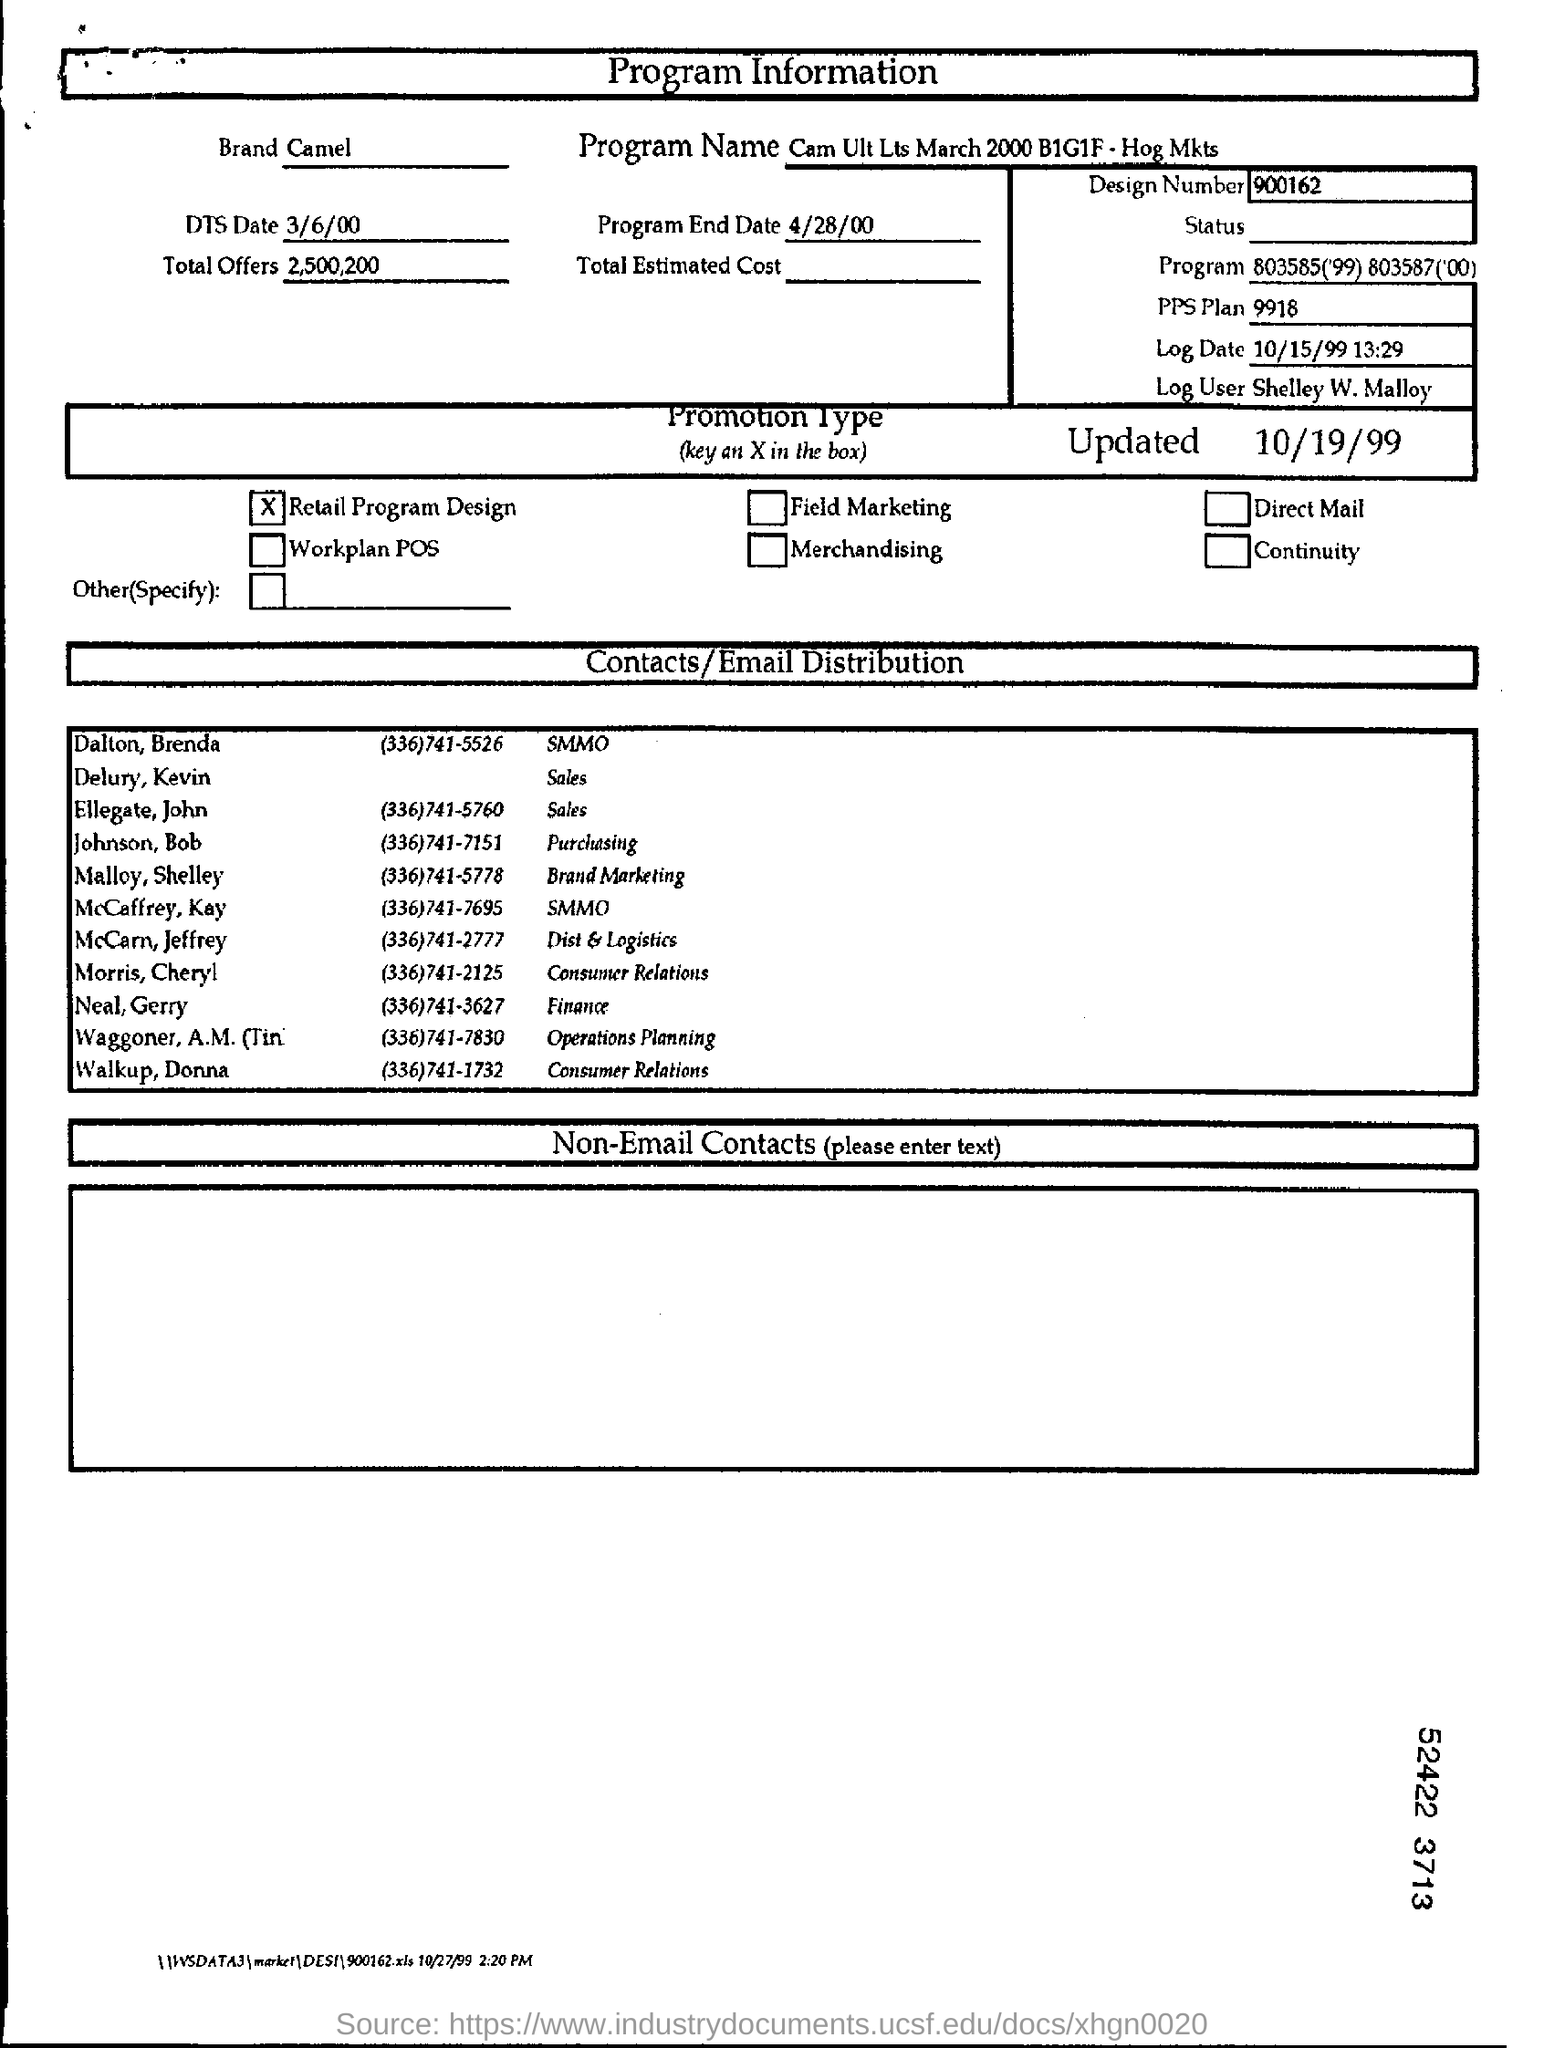Identify some key points in this picture. The brand in question is Camel. The program name is "Cam Ult LTS March 2000 B1G1F - Hog Mkts. The name of the log entry for user Shelley W. Malloy is "What is the name of log user? Shelley W. Malloy..". What is DTS Date? It is a specific date format that consists of a four-digit year, a slash, and then a two-digit day, and another slash, followed by a two-digit month, and finally a two-digit day of the week, with a period at the end. The program end date is April 28, 2000. 